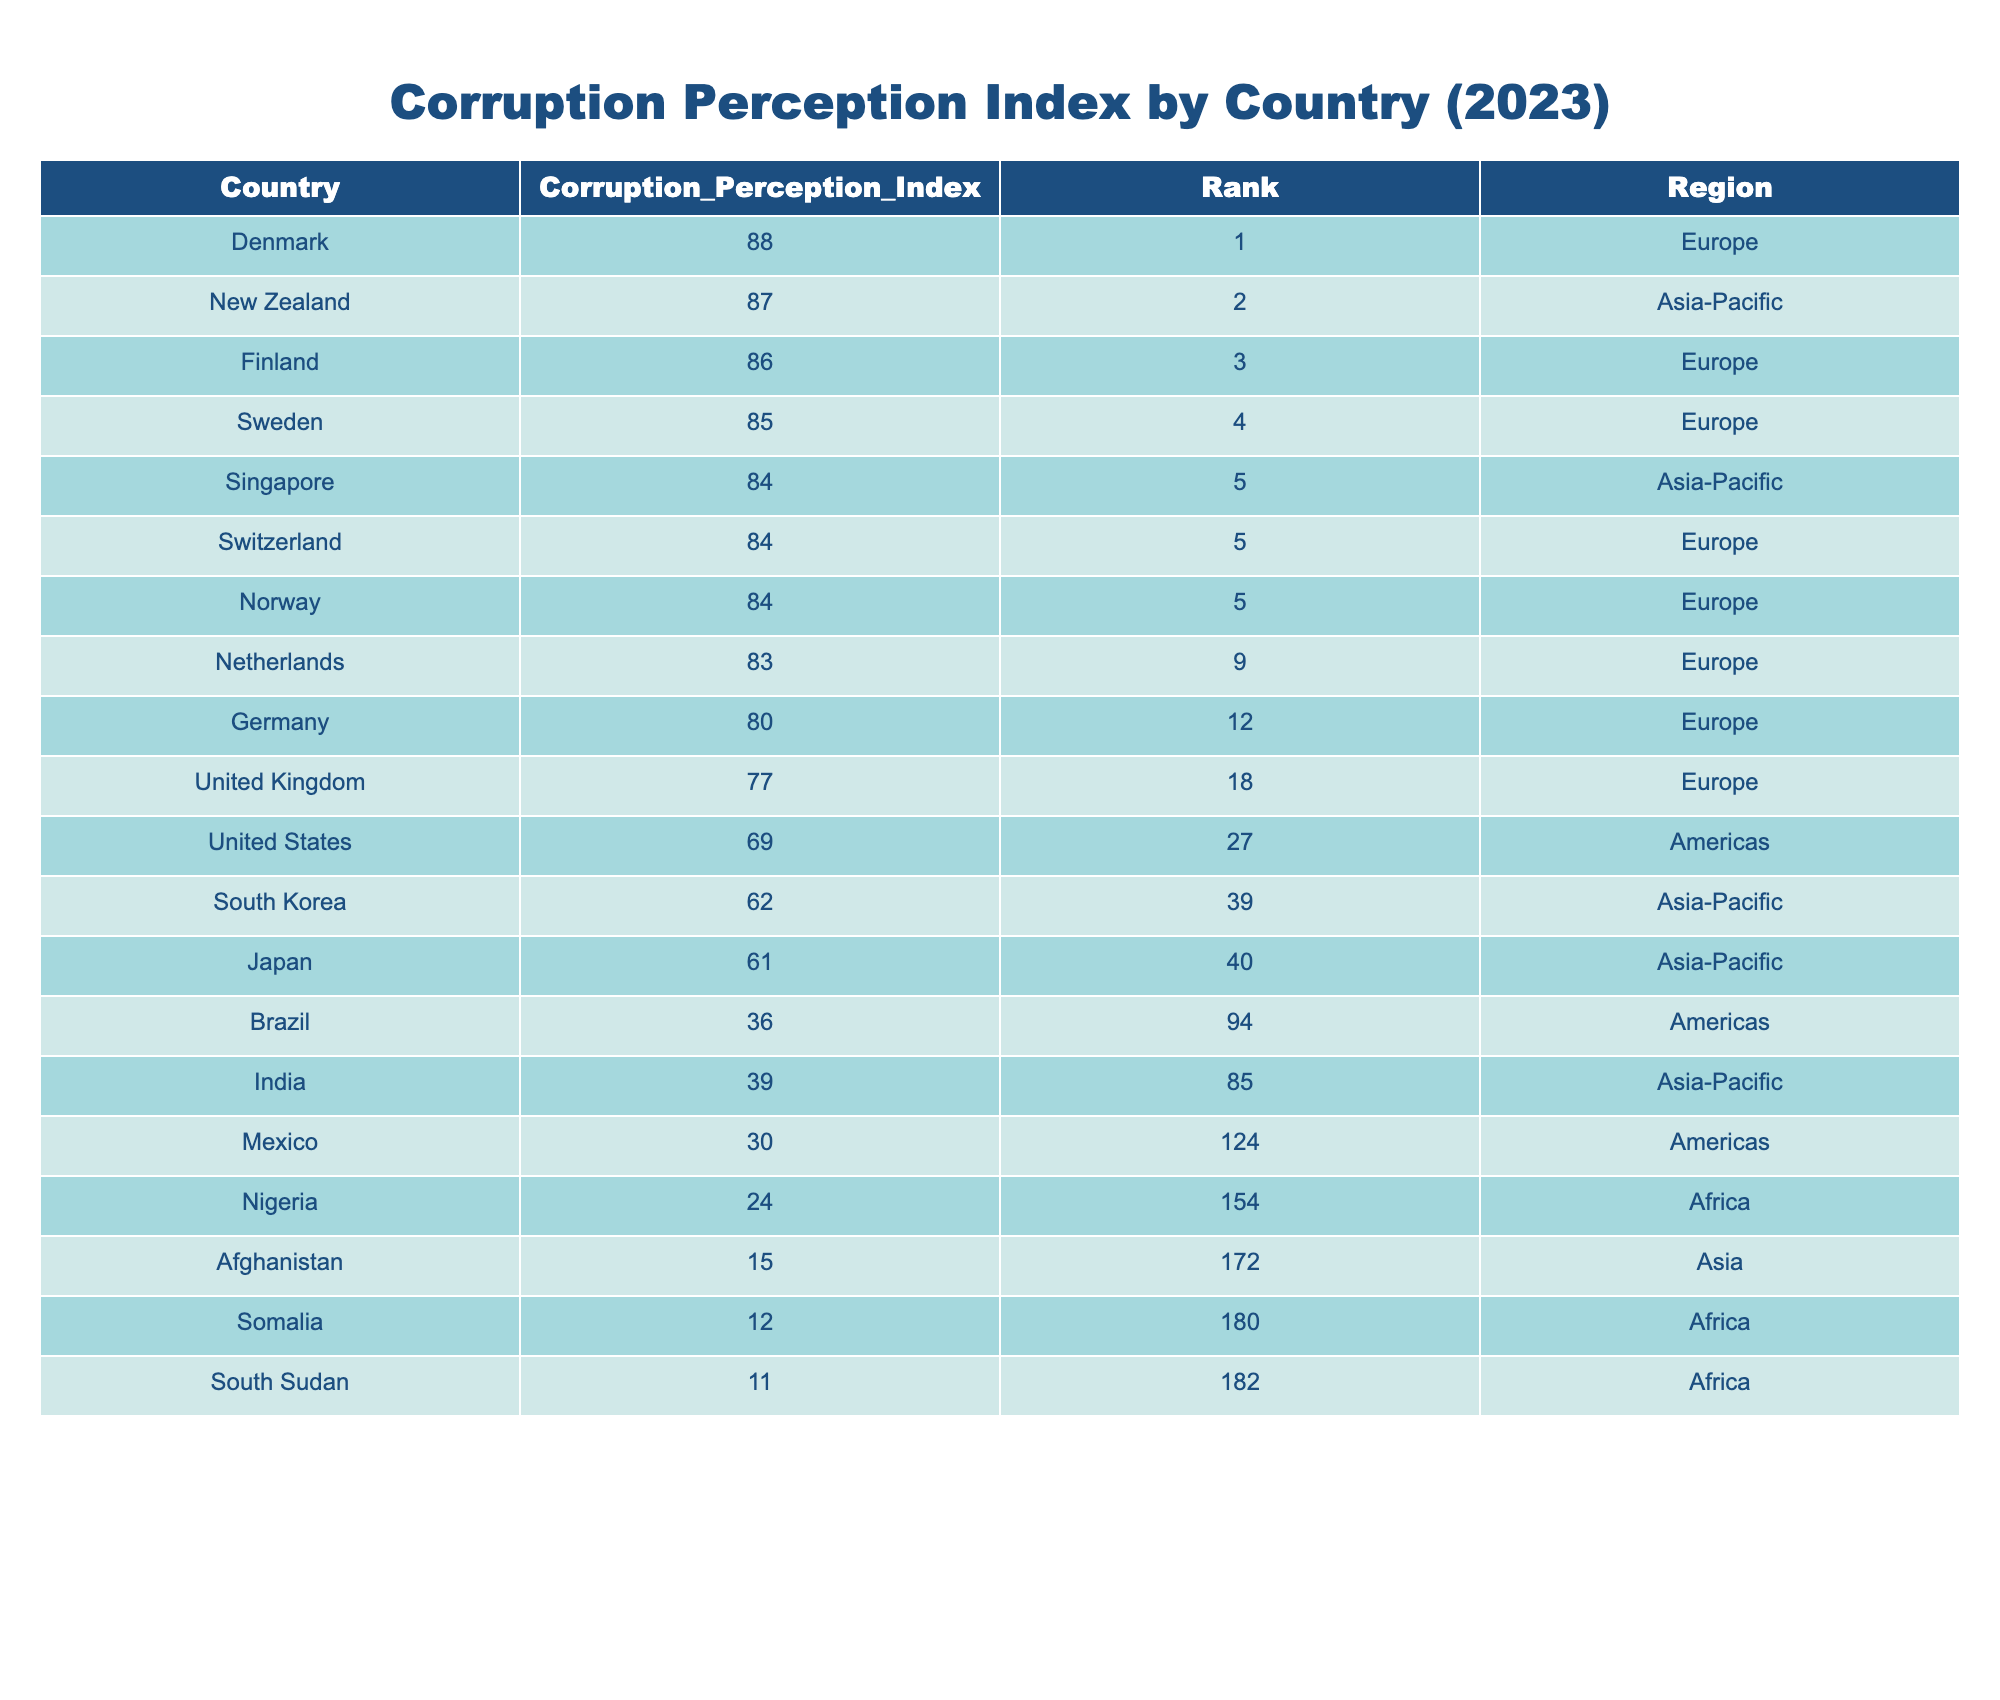What is the Corruption Perception Index of Nigeria? From the table, we can directly see that the Corruption Perception Index for Nigeria is listed in the row corresponding to Nigeria, which shows a value of 24.
Answer: 24 Which country has the highest Corruption Perception Index in Europe? The table lists several European countries, and by checking each value, Denmark has the highest index at 88, making it the top country in this region.
Answer: Denmark Is the United States ranked lower than South Korea in the Corruption Perception Index? The index indicates that the United States is ranked 27th, while South Korea is ranked 39th. Since 27 < 39, it confirms that the United States is indeed ranked lower.
Answer: Yes What is the difference in the Corruption Perception Index between Finland and Brazil? Looking at the table, Finland has an index of 86 and Brazil has 36. The difference is calculated as 86 - 36 = 50.
Answer: 50 How many countries in Africa have a Corruption Perception Index below 20? By examining the table, we can see that both Somalia (12) and South Sudan (11) have indices below 20. Therefore, there are 2 countries in Africa with a score lower than 20.
Answer: 2 Which region does India belong to, and what is its Corruption Perception Index? Referring to the table, India is indicated to be in the Asia-Pacific region with a score of 39.
Answer: Asia-Pacific, 39 Is the average Corruption Perception Index of the top three countries in the table above 86? The top three countries are Denmark (88), New Zealand (87), and Finland (86). Calculating the average: (88 + 87 + 86) / 3 = 87, which is above 86.
Answer: Yes What is the rank of Mexico compared to the United States in the Corruption Perception Index? The rank of Mexico is 124, while the United States is ranked 27. Since 124 > 27, Mexico has a lower rank, indicating higher perceived corruption.
Answer: Mexico is ranked lower 